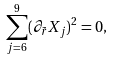<formula> <loc_0><loc_0><loc_500><loc_500>\sum _ { j = 6 } ^ { 9 } ( \partial _ { \tilde { r } } X _ { j } ) ^ { 2 } = 0 ,</formula> 